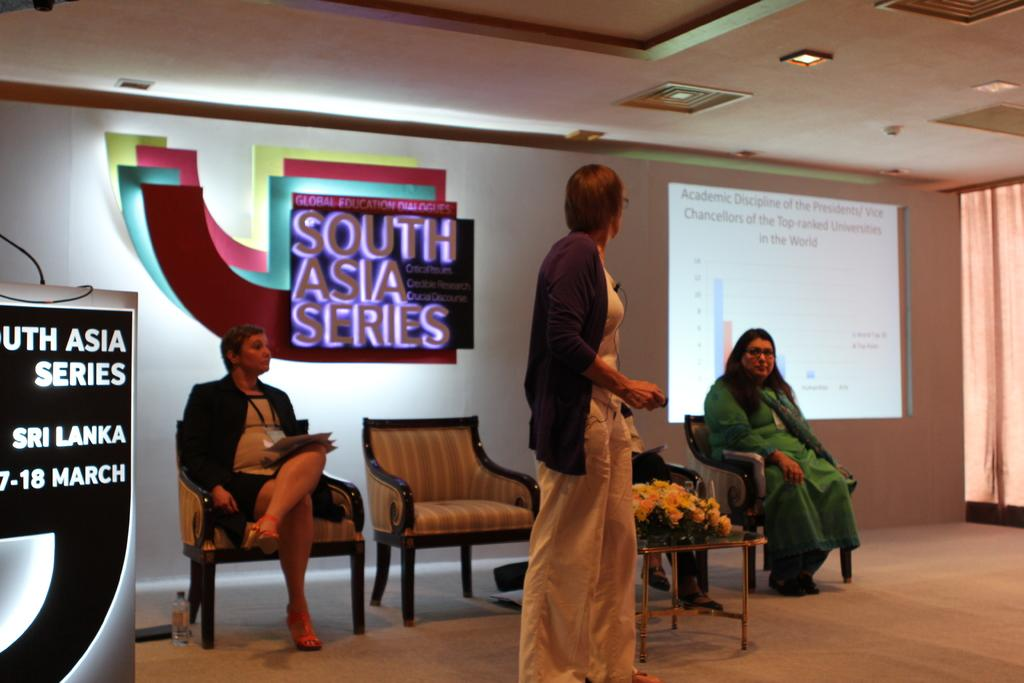How many people are present in the image? There are three people in the image, two sitting on chairs and one standing. What are the people doing in the image? The specific activity of the people cannot be determined from the provided facts. What is located at the back of the image? There is a screen at the back of the image. What is attached to the wall in the image? There is a board attached to the wall in the image. What type of haircut is the person in the image getting? There is no indication of a haircut or any hair-related activity in the image. What type of beef dish is being served in the image? There is no food or mention of food in the image. 